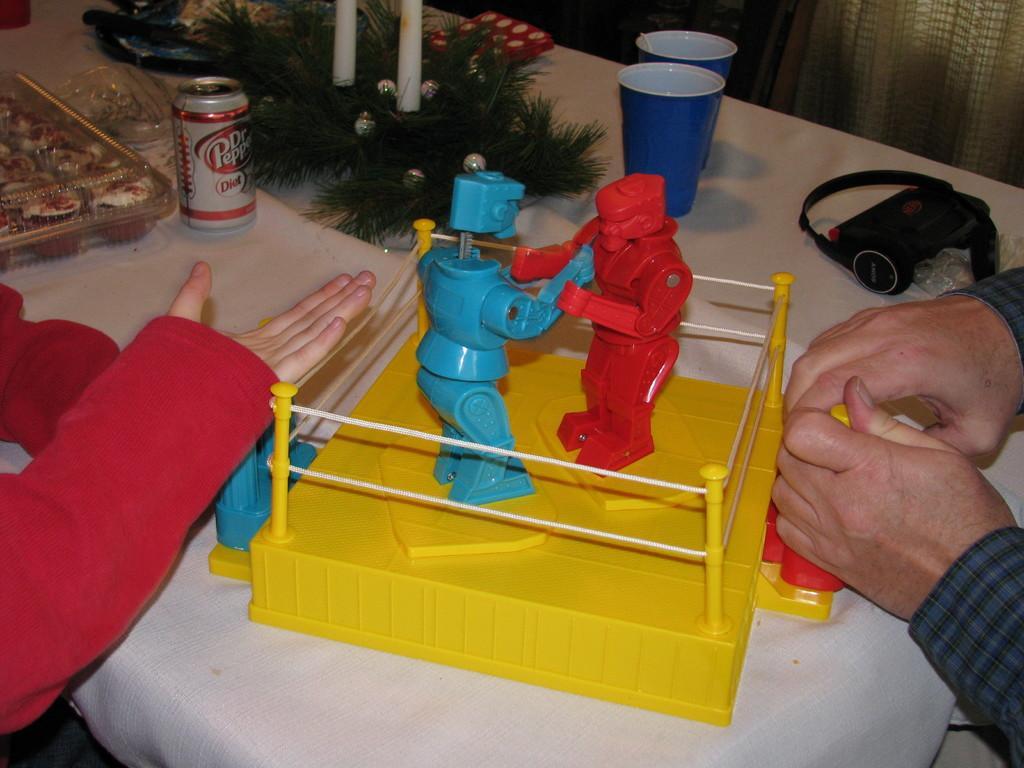How would you summarize this image in a sentence or two? In this picture I can see the hands of two persons, there are glasses, tin, there is a food item in a plastic box and there are some other objects on the table, there is a toy robot boxing game on the table. 